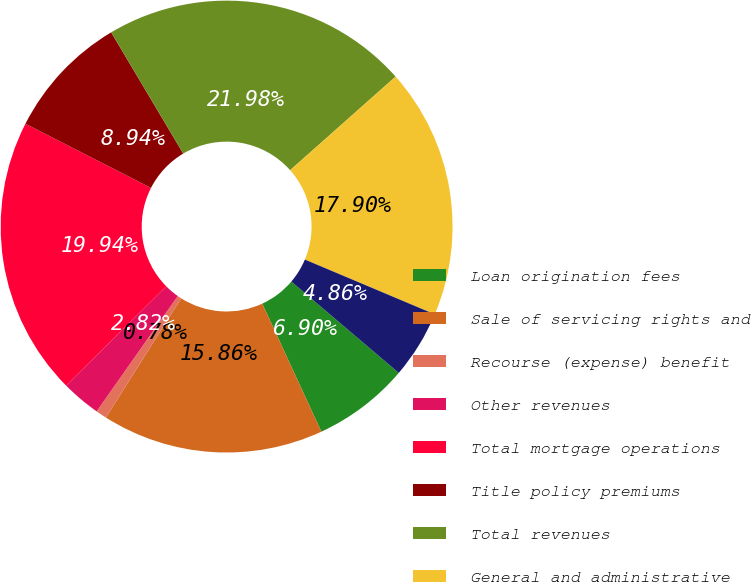<chart> <loc_0><loc_0><loc_500><loc_500><pie_chart><fcel>Loan origination fees<fcel>Sale of servicing rights and<fcel>Recourse (expense) benefit<fcel>Other revenues<fcel>Total mortgage operations<fcel>Title policy premiums<fcel>Total revenues<fcel>General and administrative<fcel>Interest and other (income)<nl><fcel>6.9%<fcel>15.86%<fcel>0.78%<fcel>2.82%<fcel>19.94%<fcel>8.94%<fcel>21.98%<fcel>17.9%<fcel>4.86%<nl></chart> 